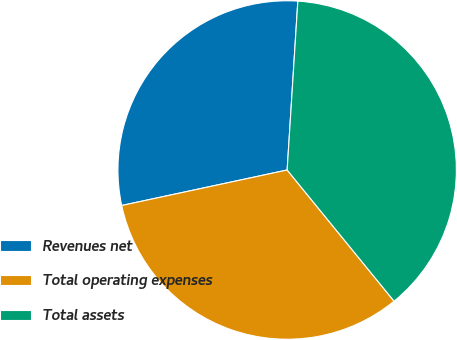<chart> <loc_0><loc_0><loc_500><loc_500><pie_chart><fcel>Revenues net<fcel>Total operating expenses<fcel>Total assets<nl><fcel>29.37%<fcel>32.52%<fcel>38.11%<nl></chart> 